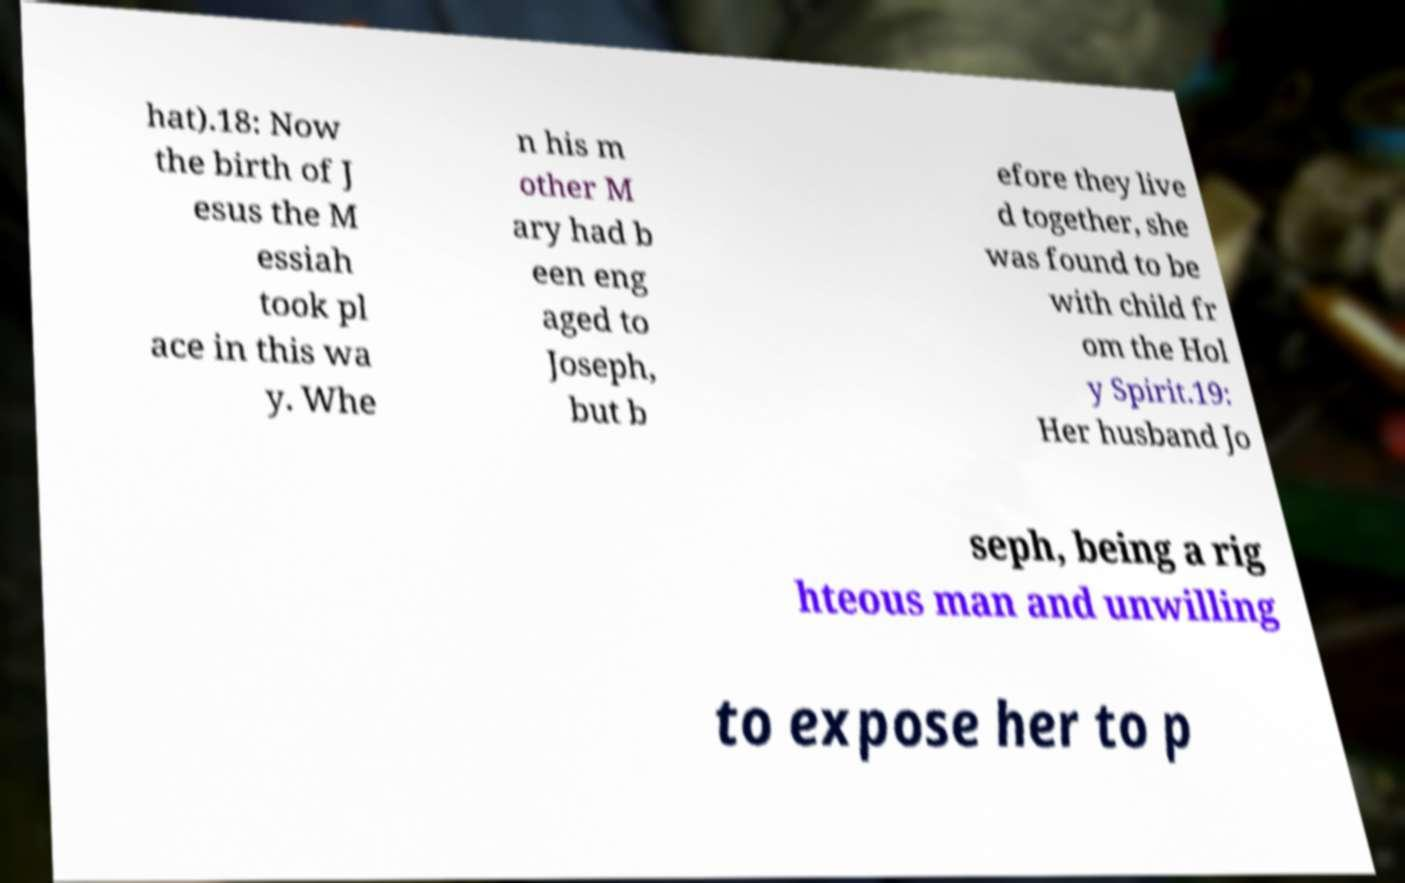There's text embedded in this image that I need extracted. Can you transcribe it verbatim? hat).18: Now the birth of J esus the M essiah took pl ace in this wa y. Whe n his m other M ary had b een eng aged to Joseph, but b efore they live d together, she was found to be with child fr om the Hol y Spirit.19: Her husband Jo seph, being a rig hteous man and unwilling to expose her to p 